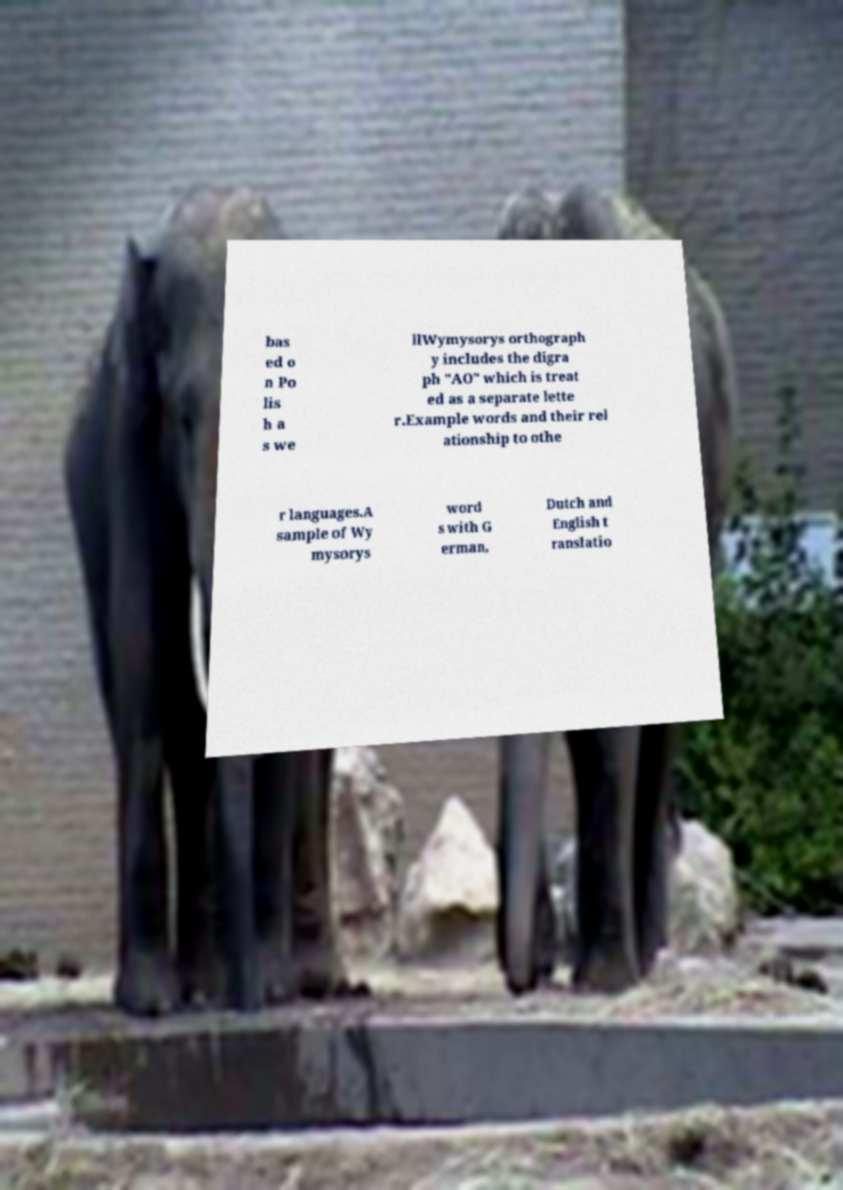What messages or text are displayed in this image? I need them in a readable, typed format. bas ed o n Po lis h a s we llWymysorys orthograph y includes the digra ph "AO" which is treat ed as a separate lette r.Example words and their rel ationship to othe r languages.A sample of Wy mysorys word s with G erman, Dutch and English t ranslatio 